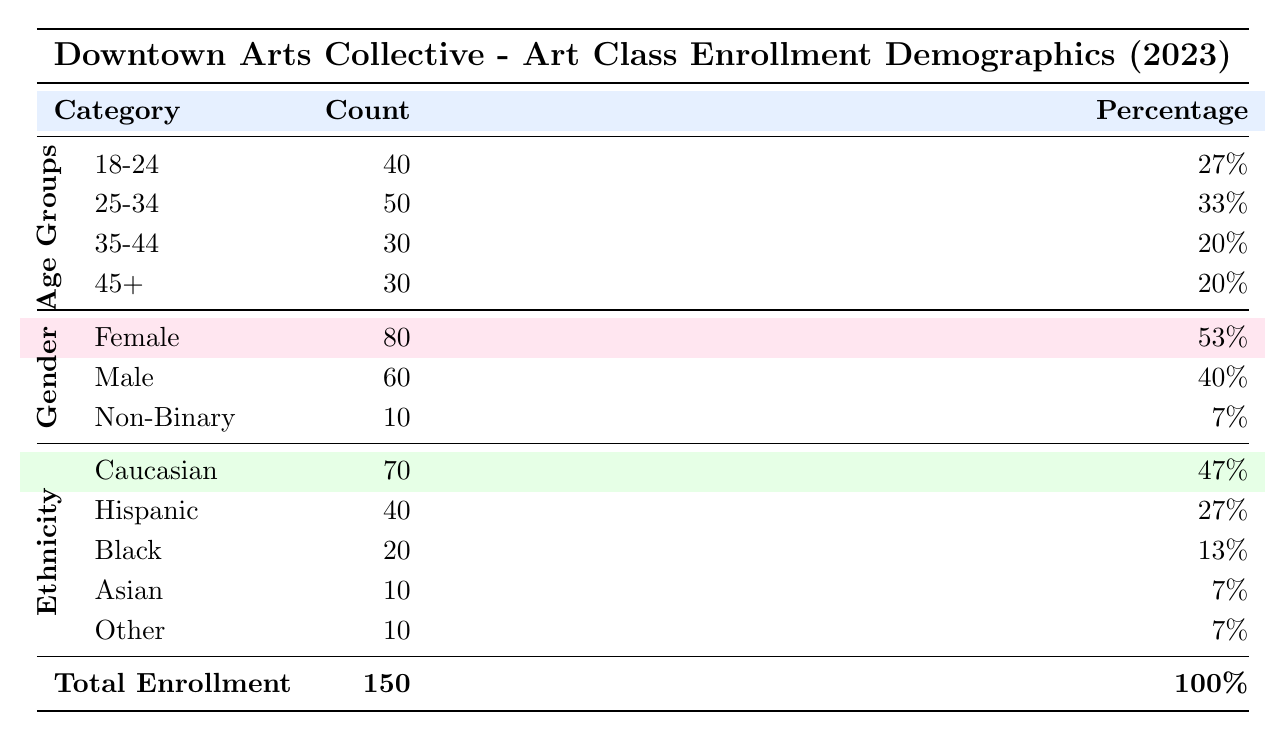What is the total enrollment for the art class? The table indicates the total enrollment number at the bottom, which is stated as 150.
Answer: 150 What percentage of enrollees are aged 25-34? In the Age Groups section, the percentage for the 25-34 age range is listed as 33%.
Answer: 33% How many male enrollees are there? Under the Gender Breakdown section, the count for Male enrollees is stated as 60.
Answer: 60 What percentage of the enrolled population identifies as Non-Binary? The Gender Breakdown lists Non-Binary enrollees with a percentage of 7%.
Answer: 7% Is the percentage of Caucasian enrollees greater than that of Black enrollees? The table shows Caucasian as 47% and Black as 13%, indicating that Caucasian is indeed greater than Black, thus the statement is true.
Answer: Yes What is the difference in enrollment counts between the age group 18-24 and the age group 35-44? The counts are 40 for 18-24 and 30 for 35-44. The difference is 40 - 30, which equals 10.
Answer: 10 What proportion of total enrollment do Hispanic enrollees represent? Hispanic enrollment is counted at 40, and the total enrollment is 150. The proportion is calculated as (40/150) x 100, which gives approximately 26.67%, rounded to 27%.
Answer: 27% Which age group has the highest enrollment? Comparing the counts: 40 (18-24), 50 (25-34), 30 (35-44), and 30 (45+), the highest is 50 in the 25-34 age group.
Answer: 25-34 Are there more females enrolled than males? The count of Female enrollees is 80 and Male enrollees is 60. Since 80 is greater than 60, the statement is true.
Answer: Yes 